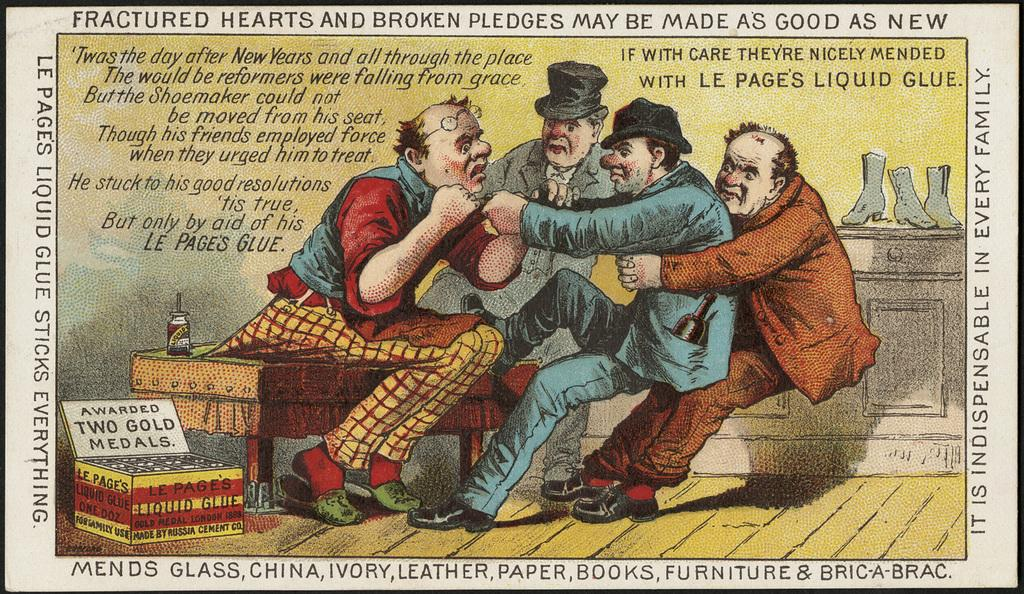What is present on the paper in the image? There are four people on the paper. Are there any other elements on the paper besides the people? Yes, there are other things on the paper. What type of cake is being compared on the quilt in the image? There is no cake or quilt present in the image; it features a paper with four people and other elements. 